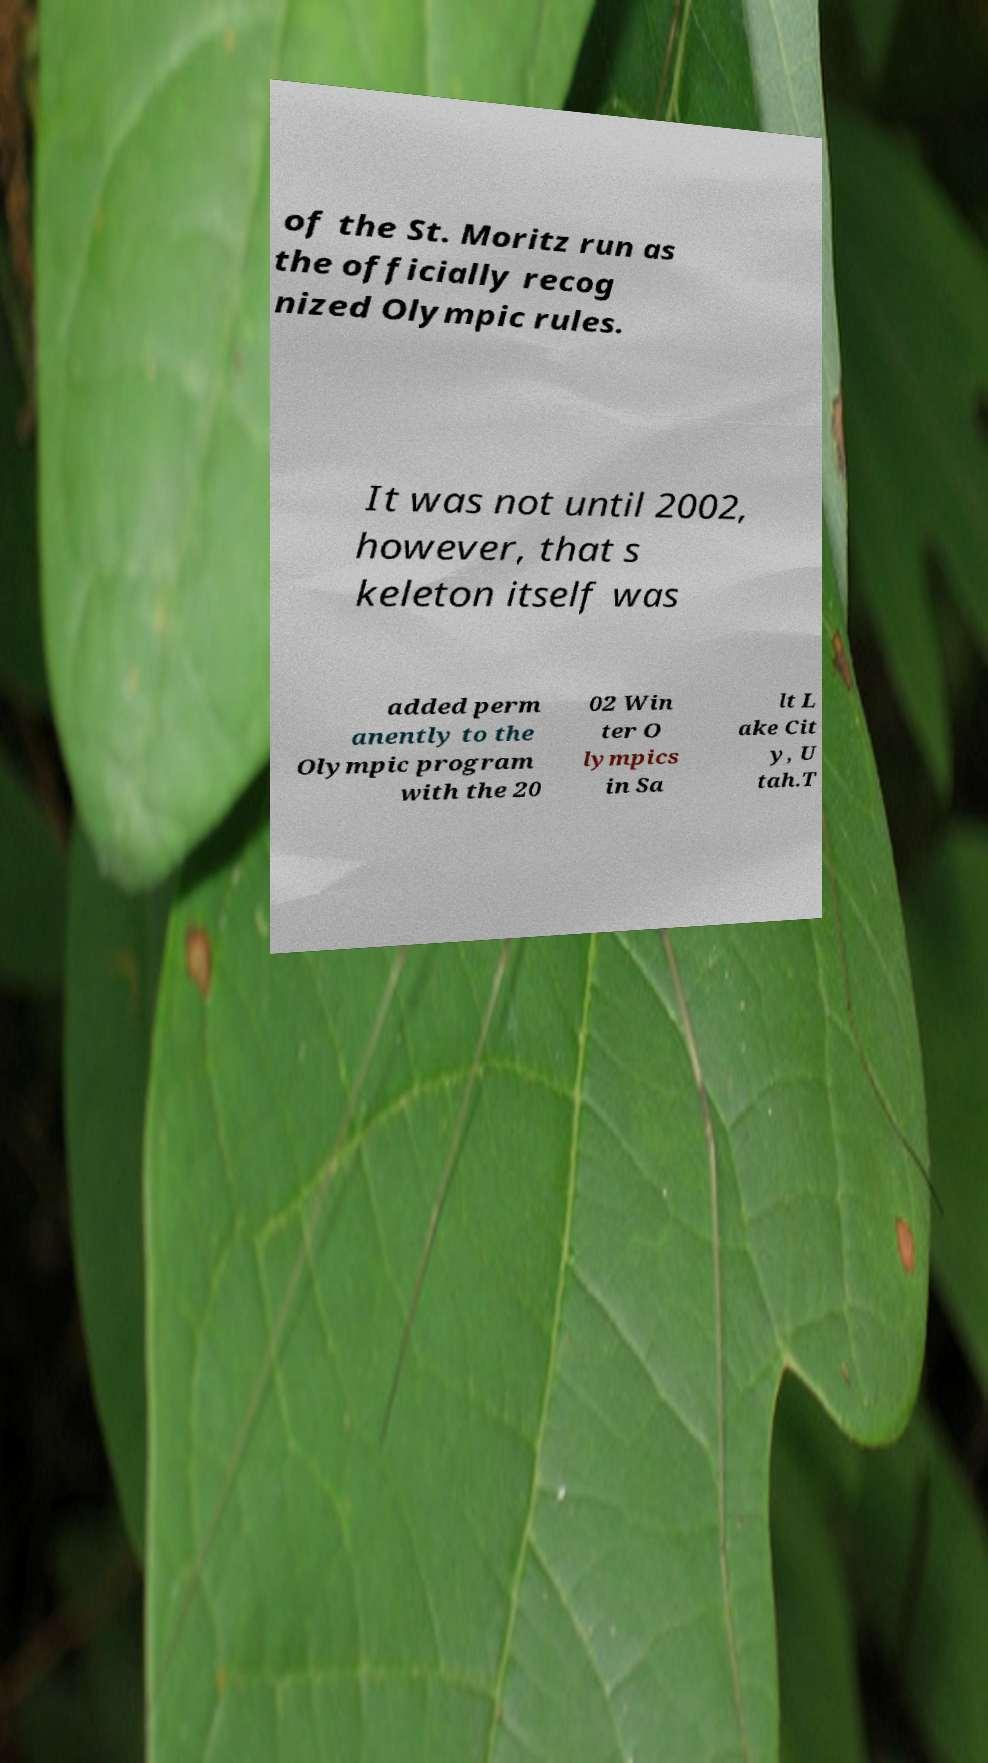For documentation purposes, I need the text within this image transcribed. Could you provide that? of the St. Moritz run as the officially recog nized Olympic rules. It was not until 2002, however, that s keleton itself was added perm anently to the Olympic program with the 20 02 Win ter O lympics in Sa lt L ake Cit y, U tah.T 